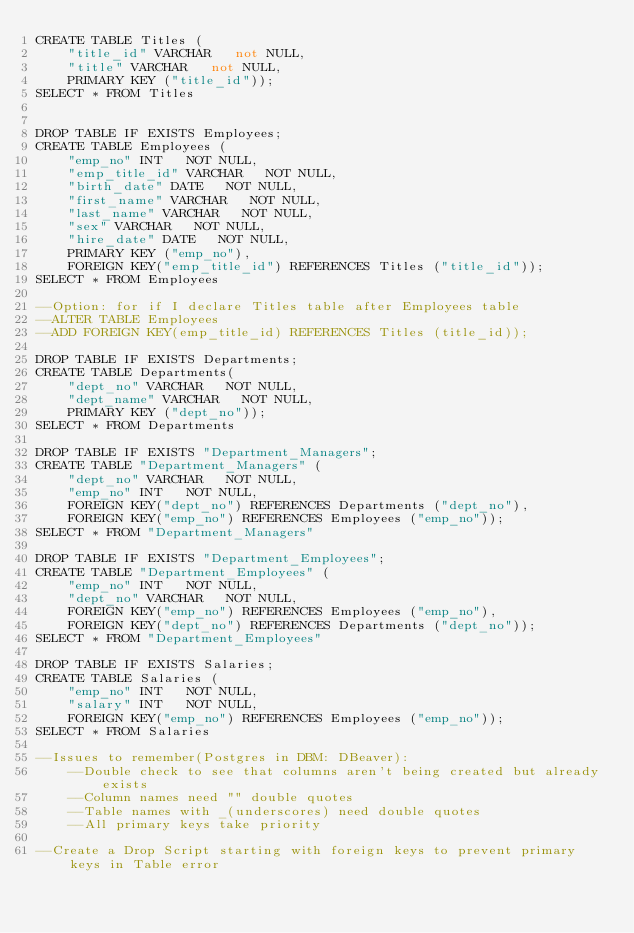Convert code to text. <code><loc_0><loc_0><loc_500><loc_500><_SQL_>CREATE TABLE Titles (
    "title_id" VARCHAR   not NULL,
    "title" VARCHAR   not NULL,
    PRIMARY KEY ("title_id"));
SELECT * FROM Titles


DROP TABLE IF EXISTS Employees;
CREATE TABLE Employees (
    "emp_no" INT   NOT NULL,
    "emp_title_id" VARCHAR   NOT NULL,
    "birth_date" DATE   NOT NULL,
    "first_name" VARCHAR   NOT NULL,
    "last_name" VARCHAR   NOT NULL,
	"sex" VARCHAR   NOT NULL,
    "hire_date" DATE   NOT NULL,
    PRIMARY KEY ("emp_no"),
    FOREIGN KEY("emp_title_id") REFERENCES Titles ("title_id"));   
SELECT * FROM Employees

--Option: for if I declare Titles table after Employees table
--ALTER TABLE Employees 
--ADD FOREIGN KEY(emp_title_id) REFERENCES Titles (title_id));

DROP TABLE IF EXISTS Departments;
CREATE TABLE Departments(
    "dept_no" VARCHAR   NOT NULL,
    "dept_name" VARCHAR   NOT NULL,
    PRIMARY KEY ("dept_no")); 
SELECT * FROM Departments

DROP TABLE IF EXISTS "Department_Managers";
CREATE TABLE "Department_Managers" (
    "dept_no" VARCHAR   NOT NULL,
    "emp_no" INT   NOT NULL,
    FOREIGN KEY("dept_no") REFERENCES Departments ("dept_no"),
    FOREIGN KEY("emp_no") REFERENCES Employees ("emp_no"));
SELECT * FROM "Department_Managers"

DROP TABLE IF EXISTS "Department_Employees";
CREATE TABLE "Department_Employees" (
    "emp_no" INT   NOT NULL,
    "dept_no" VARCHAR   NOT NULL,
    FOREIGN KEY("emp_no") REFERENCES Employees ("emp_no"),
    FOREIGN KEY("dept_no") REFERENCES Departments ("dept_no"));
SELECT * FROM "Department_Employees"

DROP TABLE IF EXISTS Salaries;
CREATE TABLE Salaries (
    "emp_no" INT   NOT NULL,
    "salary" INT   NOT NULL,
    FOREIGN KEY("emp_no") REFERENCES Employees ("emp_no"));
SELECT * FROM Salaries

--Issues to remember(Postgres in DBM: DBeaver): 
	--Double check to see that columns aren't being created but already exists
	--Column names need "" double quotes
	--Table names with _(underscores) need double quotes
	--All primary keys take priority
    
--Create a Drop Script starting with foreign keys to prevent primary keys in Table error



</code> 